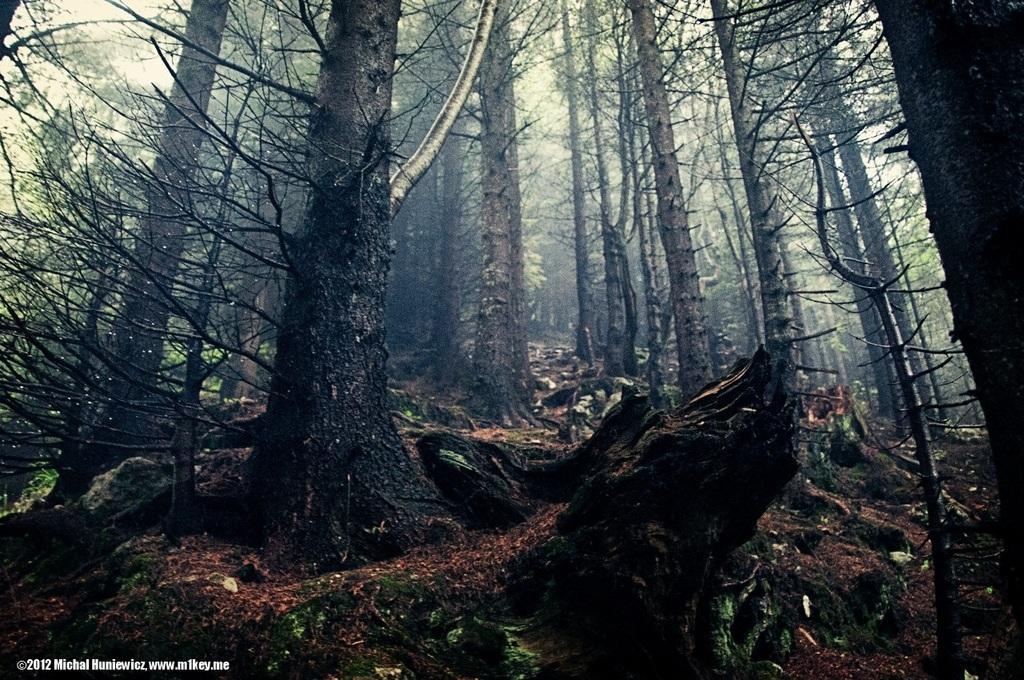How would you summarize this image in a sentence or two? In this image we can see some trees and clear sky. 